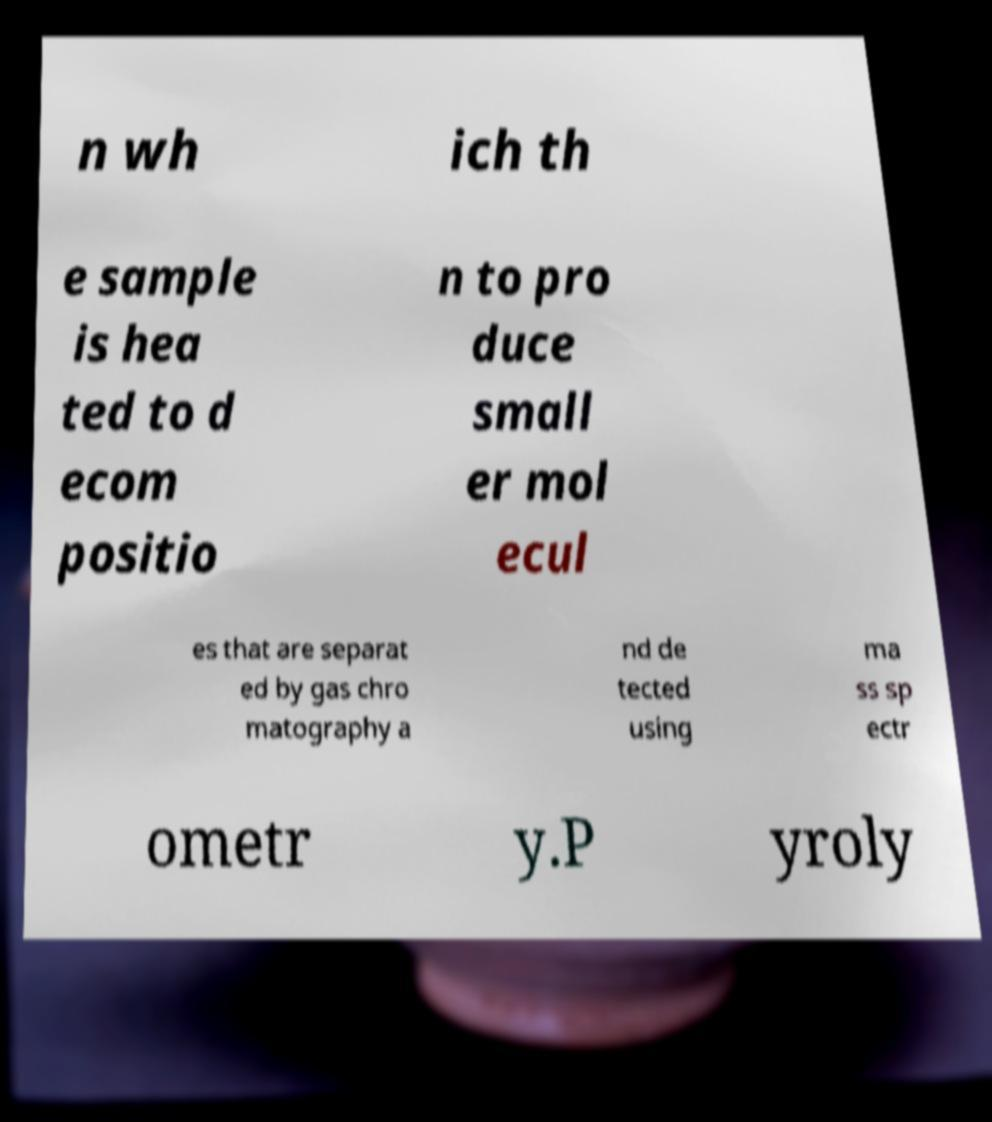Can you read and provide the text displayed in the image?This photo seems to have some interesting text. Can you extract and type it out for me? n wh ich th e sample is hea ted to d ecom positio n to pro duce small er mol ecul es that are separat ed by gas chro matography a nd de tected using ma ss sp ectr ometr y.P yroly 